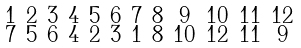<formula> <loc_0><loc_0><loc_500><loc_500>\begin{smallmatrix} 1 & 2 & 3 & 4 & 5 & 6 & 7 & 8 & 9 & 1 0 & 1 1 & 1 2 \\ 7 & 5 & 6 & 4 & 2 & 3 & 1 & 8 & 1 0 & 1 2 & 1 1 & 9 \end{smallmatrix}</formula> 